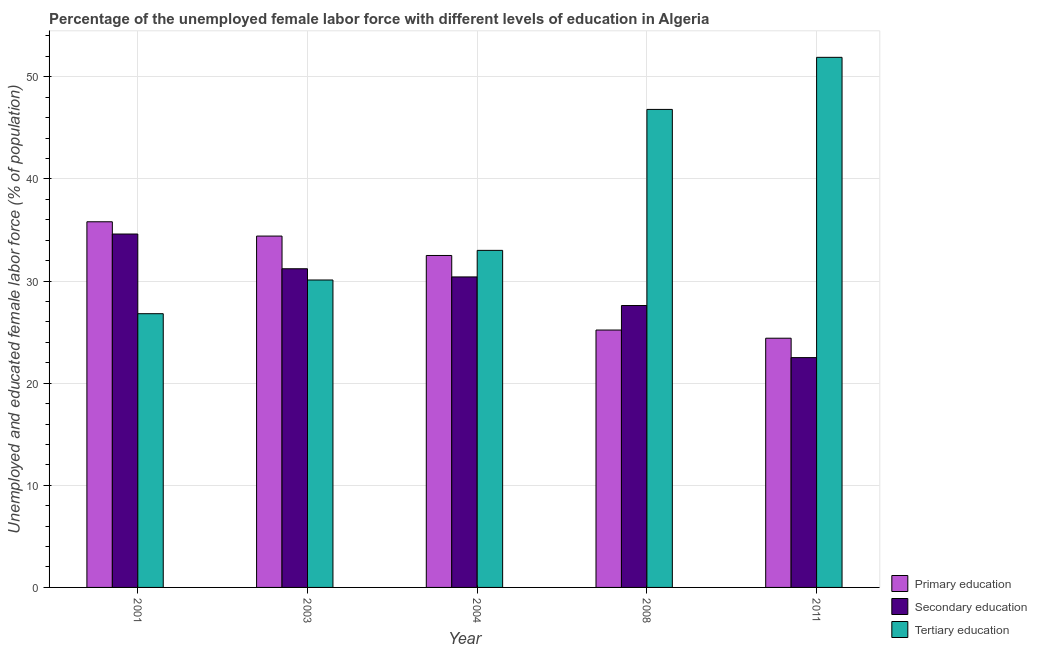How many different coloured bars are there?
Provide a succinct answer. 3. How many groups of bars are there?
Your answer should be very brief. 5. Are the number of bars per tick equal to the number of legend labels?
Provide a succinct answer. Yes. Are the number of bars on each tick of the X-axis equal?
Ensure brevity in your answer.  Yes. How many bars are there on the 1st tick from the left?
Make the answer very short. 3. In how many cases, is the number of bars for a given year not equal to the number of legend labels?
Offer a terse response. 0. Across all years, what is the maximum percentage of female labor force who received primary education?
Offer a terse response. 35.8. Across all years, what is the minimum percentage of female labor force who received secondary education?
Make the answer very short. 22.5. What is the total percentage of female labor force who received secondary education in the graph?
Your answer should be compact. 146.3. What is the difference between the percentage of female labor force who received primary education in 2004 and that in 2011?
Your response must be concise. 8.1. What is the difference between the percentage of female labor force who received primary education in 2003 and the percentage of female labor force who received secondary education in 2001?
Ensure brevity in your answer.  -1.4. What is the average percentage of female labor force who received tertiary education per year?
Give a very brief answer. 37.72. In the year 2011, what is the difference between the percentage of female labor force who received tertiary education and percentage of female labor force who received secondary education?
Provide a succinct answer. 0. What is the ratio of the percentage of female labor force who received secondary education in 2003 to that in 2008?
Ensure brevity in your answer.  1.13. Is the difference between the percentage of female labor force who received secondary education in 2004 and 2011 greater than the difference between the percentage of female labor force who received primary education in 2004 and 2011?
Provide a succinct answer. No. What is the difference between the highest and the second highest percentage of female labor force who received secondary education?
Ensure brevity in your answer.  3.4. What is the difference between the highest and the lowest percentage of female labor force who received secondary education?
Ensure brevity in your answer.  12.1. In how many years, is the percentage of female labor force who received secondary education greater than the average percentage of female labor force who received secondary education taken over all years?
Your response must be concise. 3. What does the 2nd bar from the left in 2004 represents?
Your answer should be very brief. Secondary education. Is it the case that in every year, the sum of the percentage of female labor force who received primary education and percentage of female labor force who received secondary education is greater than the percentage of female labor force who received tertiary education?
Give a very brief answer. No. Are all the bars in the graph horizontal?
Provide a succinct answer. No. How many years are there in the graph?
Provide a short and direct response. 5. What is the difference between two consecutive major ticks on the Y-axis?
Offer a very short reply. 10. How many legend labels are there?
Provide a short and direct response. 3. How are the legend labels stacked?
Your answer should be very brief. Vertical. What is the title of the graph?
Keep it short and to the point. Percentage of the unemployed female labor force with different levels of education in Algeria. What is the label or title of the Y-axis?
Ensure brevity in your answer.  Unemployed and educated female labor force (% of population). What is the Unemployed and educated female labor force (% of population) of Primary education in 2001?
Your answer should be compact. 35.8. What is the Unemployed and educated female labor force (% of population) in Secondary education in 2001?
Offer a terse response. 34.6. What is the Unemployed and educated female labor force (% of population) in Tertiary education in 2001?
Give a very brief answer. 26.8. What is the Unemployed and educated female labor force (% of population) in Primary education in 2003?
Your answer should be compact. 34.4. What is the Unemployed and educated female labor force (% of population) in Secondary education in 2003?
Give a very brief answer. 31.2. What is the Unemployed and educated female labor force (% of population) of Tertiary education in 2003?
Your answer should be very brief. 30.1. What is the Unemployed and educated female labor force (% of population) in Primary education in 2004?
Give a very brief answer. 32.5. What is the Unemployed and educated female labor force (% of population) in Secondary education in 2004?
Make the answer very short. 30.4. What is the Unemployed and educated female labor force (% of population) of Primary education in 2008?
Offer a very short reply. 25.2. What is the Unemployed and educated female labor force (% of population) in Secondary education in 2008?
Offer a very short reply. 27.6. What is the Unemployed and educated female labor force (% of population) of Tertiary education in 2008?
Your answer should be compact. 46.8. What is the Unemployed and educated female labor force (% of population) in Primary education in 2011?
Offer a very short reply. 24.4. What is the Unemployed and educated female labor force (% of population) of Tertiary education in 2011?
Ensure brevity in your answer.  51.9. Across all years, what is the maximum Unemployed and educated female labor force (% of population) in Primary education?
Keep it short and to the point. 35.8. Across all years, what is the maximum Unemployed and educated female labor force (% of population) in Secondary education?
Ensure brevity in your answer.  34.6. Across all years, what is the maximum Unemployed and educated female labor force (% of population) in Tertiary education?
Your answer should be compact. 51.9. Across all years, what is the minimum Unemployed and educated female labor force (% of population) in Primary education?
Your answer should be very brief. 24.4. Across all years, what is the minimum Unemployed and educated female labor force (% of population) in Tertiary education?
Give a very brief answer. 26.8. What is the total Unemployed and educated female labor force (% of population) of Primary education in the graph?
Your answer should be very brief. 152.3. What is the total Unemployed and educated female labor force (% of population) in Secondary education in the graph?
Give a very brief answer. 146.3. What is the total Unemployed and educated female labor force (% of population) in Tertiary education in the graph?
Keep it short and to the point. 188.6. What is the difference between the Unemployed and educated female labor force (% of population) in Primary education in 2001 and that in 2003?
Offer a terse response. 1.4. What is the difference between the Unemployed and educated female labor force (% of population) in Secondary education in 2001 and that in 2003?
Provide a succinct answer. 3.4. What is the difference between the Unemployed and educated female labor force (% of population) of Tertiary education in 2001 and that in 2003?
Your answer should be compact. -3.3. What is the difference between the Unemployed and educated female labor force (% of population) of Primary education in 2001 and that in 2004?
Offer a very short reply. 3.3. What is the difference between the Unemployed and educated female labor force (% of population) of Secondary education in 2001 and that in 2008?
Your response must be concise. 7. What is the difference between the Unemployed and educated female labor force (% of population) in Tertiary education in 2001 and that in 2008?
Offer a terse response. -20. What is the difference between the Unemployed and educated female labor force (% of population) in Primary education in 2001 and that in 2011?
Provide a short and direct response. 11.4. What is the difference between the Unemployed and educated female labor force (% of population) in Secondary education in 2001 and that in 2011?
Make the answer very short. 12.1. What is the difference between the Unemployed and educated female labor force (% of population) in Tertiary education in 2001 and that in 2011?
Your answer should be very brief. -25.1. What is the difference between the Unemployed and educated female labor force (% of population) of Tertiary education in 2003 and that in 2004?
Ensure brevity in your answer.  -2.9. What is the difference between the Unemployed and educated female labor force (% of population) of Primary education in 2003 and that in 2008?
Ensure brevity in your answer.  9.2. What is the difference between the Unemployed and educated female labor force (% of population) of Tertiary education in 2003 and that in 2008?
Ensure brevity in your answer.  -16.7. What is the difference between the Unemployed and educated female labor force (% of population) of Secondary education in 2003 and that in 2011?
Offer a terse response. 8.7. What is the difference between the Unemployed and educated female labor force (% of population) in Tertiary education in 2003 and that in 2011?
Make the answer very short. -21.8. What is the difference between the Unemployed and educated female labor force (% of population) of Tertiary education in 2004 and that in 2008?
Your response must be concise. -13.8. What is the difference between the Unemployed and educated female labor force (% of population) in Tertiary education in 2004 and that in 2011?
Offer a very short reply. -18.9. What is the difference between the Unemployed and educated female labor force (% of population) of Primary education in 2008 and that in 2011?
Provide a succinct answer. 0.8. What is the difference between the Unemployed and educated female labor force (% of population) of Secondary education in 2008 and that in 2011?
Your response must be concise. 5.1. What is the difference between the Unemployed and educated female labor force (% of population) in Tertiary education in 2008 and that in 2011?
Ensure brevity in your answer.  -5.1. What is the difference between the Unemployed and educated female labor force (% of population) in Primary education in 2001 and the Unemployed and educated female labor force (% of population) in Tertiary education in 2003?
Keep it short and to the point. 5.7. What is the difference between the Unemployed and educated female labor force (% of population) of Primary education in 2001 and the Unemployed and educated female labor force (% of population) of Tertiary education in 2004?
Offer a terse response. 2.8. What is the difference between the Unemployed and educated female labor force (% of population) of Primary education in 2001 and the Unemployed and educated female labor force (% of population) of Tertiary education in 2008?
Offer a very short reply. -11. What is the difference between the Unemployed and educated female labor force (% of population) in Secondary education in 2001 and the Unemployed and educated female labor force (% of population) in Tertiary education in 2008?
Make the answer very short. -12.2. What is the difference between the Unemployed and educated female labor force (% of population) in Primary education in 2001 and the Unemployed and educated female labor force (% of population) in Secondary education in 2011?
Your answer should be compact. 13.3. What is the difference between the Unemployed and educated female labor force (% of population) in Primary education in 2001 and the Unemployed and educated female labor force (% of population) in Tertiary education in 2011?
Offer a very short reply. -16.1. What is the difference between the Unemployed and educated female labor force (% of population) in Secondary education in 2001 and the Unemployed and educated female labor force (% of population) in Tertiary education in 2011?
Ensure brevity in your answer.  -17.3. What is the difference between the Unemployed and educated female labor force (% of population) of Primary education in 2003 and the Unemployed and educated female labor force (% of population) of Tertiary education in 2004?
Offer a terse response. 1.4. What is the difference between the Unemployed and educated female labor force (% of population) of Secondary education in 2003 and the Unemployed and educated female labor force (% of population) of Tertiary education in 2008?
Make the answer very short. -15.6. What is the difference between the Unemployed and educated female labor force (% of population) in Primary education in 2003 and the Unemployed and educated female labor force (% of population) in Secondary education in 2011?
Provide a succinct answer. 11.9. What is the difference between the Unemployed and educated female labor force (% of population) of Primary education in 2003 and the Unemployed and educated female labor force (% of population) of Tertiary education in 2011?
Offer a terse response. -17.5. What is the difference between the Unemployed and educated female labor force (% of population) in Secondary education in 2003 and the Unemployed and educated female labor force (% of population) in Tertiary education in 2011?
Give a very brief answer. -20.7. What is the difference between the Unemployed and educated female labor force (% of population) of Primary education in 2004 and the Unemployed and educated female labor force (% of population) of Tertiary education in 2008?
Your answer should be compact. -14.3. What is the difference between the Unemployed and educated female labor force (% of population) of Secondary education in 2004 and the Unemployed and educated female labor force (% of population) of Tertiary education in 2008?
Provide a short and direct response. -16.4. What is the difference between the Unemployed and educated female labor force (% of population) of Primary education in 2004 and the Unemployed and educated female labor force (% of population) of Tertiary education in 2011?
Offer a terse response. -19.4. What is the difference between the Unemployed and educated female labor force (% of population) in Secondary education in 2004 and the Unemployed and educated female labor force (% of population) in Tertiary education in 2011?
Make the answer very short. -21.5. What is the difference between the Unemployed and educated female labor force (% of population) in Primary education in 2008 and the Unemployed and educated female labor force (% of population) in Tertiary education in 2011?
Offer a very short reply. -26.7. What is the difference between the Unemployed and educated female labor force (% of population) in Secondary education in 2008 and the Unemployed and educated female labor force (% of population) in Tertiary education in 2011?
Give a very brief answer. -24.3. What is the average Unemployed and educated female labor force (% of population) of Primary education per year?
Keep it short and to the point. 30.46. What is the average Unemployed and educated female labor force (% of population) in Secondary education per year?
Your answer should be very brief. 29.26. What is the average Unemployed and educated female labor force (% of population) in Tertiary education per year?
Your answer should be very brief. 37.72. In the year 2001, what is the difference between the Unemployed and educated female labor force (% of population) of Secondary education and Unemployed and educated female labor force (% of population) of Tertiary education?
Keep it short and to the point. 7.8. In the year 2003, what is the difference between the Unemployed and educated female labor force (% of population) in Primary education and Unemployed and educated female labor force (% of population) in Secondary education?
Offer a very short reply. 3.2. In the year 2003, what is the difference between the Unemployed and educated female labor force (% of population) in Primary education and Unemployed and educated female labor force (% of population) in Tertiary education?
Provide a short and direct response. 4.3. In the year 2004, what is the difference between the Unemployed and educated female labor force (% of population) in Primary education and Unemployed and educated female labor force (% of population) in Tertiary education?
Offer a terse response. -0.5. In the year 2008, what is the difference between the Unemployed and educated female labor force (% of population) in Primary education and Unemployed and educated female labor force (% of population) in Secondary education?
Your answer should be compact. -2.4. In the year 2008, what is the difference between the Unemployed and educated female labor force (% of population) of Primary education and Unemployed and educated female labor force (% of population) of Tertiary education?
Ensure brevity in your answer.  -21.6. In the year 2008, what is the difference between the Unemployed and educated female labor force (% of population) of Secondary education and Unemployed and educated female labor force (% of population) of Tertiary education?
Keep it short and to the point. -19.2. In the year 2011, what is the difference between the Unemployed and educated female labor force (% of population) in Primary education and Unemployed and educated female labor force (% of population) in Tertiary education?
Make the answer very short. -27.5. In the year 2011, what is the difference between the Unemployed and educated female labor force (% of population) in Secondary education and Unemployed and educated female labor force (% of population) in Tertiary education?
Provide a short and direct response. -29.4. What is the ratio of the Unemployed and educated female labor force (% of population) in Primary education in 2001 to that in 2003?
Ensure brevity in your answer.  1.04. What is the ratio of the Unemployed and educated female labor force (% of population) of Secondary education in 2001 to that in 2003?
Your response must be concise. 1.11. What is the ratio of the Unemployed and educated female labor force (% of population) in Tertiary education in 2001 to that in 2003?
Keep it short and to the point. 0.89. What is the ratio of the Unemployed and educated female labor force (% of population) in Primary education in 2001 to that in 2004?
Your response must be concise. 1.1. What is the ratio of the Unemployed and educated female labor force (% of population) of Secondary education in 2001 to that in 2004?
Offer a terse response. 1.14. What is the ratio of the Unemployed and educated female labor force (% of population) in Tertiary education in 2001 to that in 2004?
Your answer should be compact. 0.81. What is the ratio of the Unemployed and educated female labor force (% of population) of Primary education in 2001 to that in 2008?
Ensure brevity in your answer.  1.42. What is the ratio of the Unemployed and educated female labor force (% of population) in Secondary education in 2001 to that in 2008?
Your answer should be compact. 1.25. What is the ratio of the Unemployed and educated female labor force (% of population) in Tertiary education in 2001 to that in 2008?
Your answer should be very brief. 0.57. What is the ratio of the Unemployed and educated female labor force (% of population) of Primary education in 2001 to that in 2011?
Provide a succinct answer. 1.47. What is the ratio of the Unemployed and educated female labor force (% of population) in Secondary education in 2001 to that in 2011?
Give a very brief answer. 1.54. What is the ratio of the Unemployed and educated female labor force (% of population) of Tertiary education in 2001 to that in 2011?
Your answer should be compact. 0.52. What is the ratio of the Unemployed and educated female labor force (% of population) of Primary education in 2003 to that in 2004?
Give a very brief answer. 1.06. What is the ratio of the Unemployed and educated female labor force (% of population) of Secondary education in 2003 to that in 2004?
Give a very brief answer. 1.03. What is the ratio of the Unemployed and educated female labor force (% of population) in Tertiary education in 2003 to that in 2004?
Ensure brevity in your answer.  0.91. What is the ratio of the Unemployed and educated female labor force (% of population) of Primary education in 2003 to that in 2008?
Ensure brevity in your answer.  1.37. What is the ratio of the Unemployed and educated female labor force (% of population) of Secondary education in 2003 to that in 2008?
Make the answer very short. 1.13. What is the ratio of the Unemployed and educated female labor force (% of population) of Tertiary education in 2003 to that in 2008?
Keep it short and to the point. 0.64. What is the ratio of the Unemployed and educated female labor force (% of population) in Primary education in 2003 to that in 2011?
Offer a terse response. 1.41. What is the ratio of the Unemployed and educated female labor force (% of population) in Secondary education in 2003 to that in 2011?
Offer a very short reply. 1.39. What is the ratio of the Unemployed and educated female labor force (% of population) of Tertiary education in 2003 to that in 2011?
Ensure brevity in your answer.  0.58. What is the ratio of the Unemployed and educated female labor force (% of population) of Primary education in 2004 to that in 2008?
Give a very brief answer. 1.29. What is the ratio of the Unemployed and educated female labor force (% of population) of Secondary education in 2004 to that in 2008?
Provide a short and direct response. 1.1. What is the ratio of the Unemployed and educated female labor force (% of population) of Tertiary education in 2004 to that in 2008?
Offer a terse response. 0.71. What is the ratio of the Unemployed and educated female labor force (% of population) in Primary education in 2004 to that in 2011?
Your response must be concise. 1.33. What is the ratio of the Unemployed and educated female labor force (% of population) in Secondary education in 2004 to that in 2011?
Make the answer very short. 1.35. What is the ratio of the Unemployed and educated female labor force (% of population) in Tertiary education in 2004 to that in 2011?
Your answer should be compact. 0.64. What is the ratio of the Unemployed and educated female labor force (% of population) of Primary education in 2008 to that in 2011?
Keep it short and to the point. 1.03. What is the ratio of the Unemployed and educated female labor force (% of population) in Secondary education in 2008 to that in 2011?
Your answer should be very brief. 1.23. What is the ratio of the Unemployed and educated female labor force (% of population) in Tertiary education in 2008 to that in 2011?
Your response must be concise. 0.9. What is the difference between the highest and the second highest Unemployed and educated female labor force (% of population) in Primary education?
Make the answer very short. 1.4. What is the difference between the highest and the second highest Unemployed and educated female labor force (% of population) of Secondary education?
Make the answer very short. 3.4. What is the difference between the highest and the second highest Unemployed and educated female labor force (% of population) of Tertiary education?
Provide a succinct answer. 5.1. What is the difference between the highest and the lowest Unemployed and educated female labor force (% of population) in Secondary education?
Your response must be concise. 12.1. What is the difference between the highest and the lowest Unemployed and educated female labor force (% of population) of Tertiary education?
Make the answer very short. 25.1. 